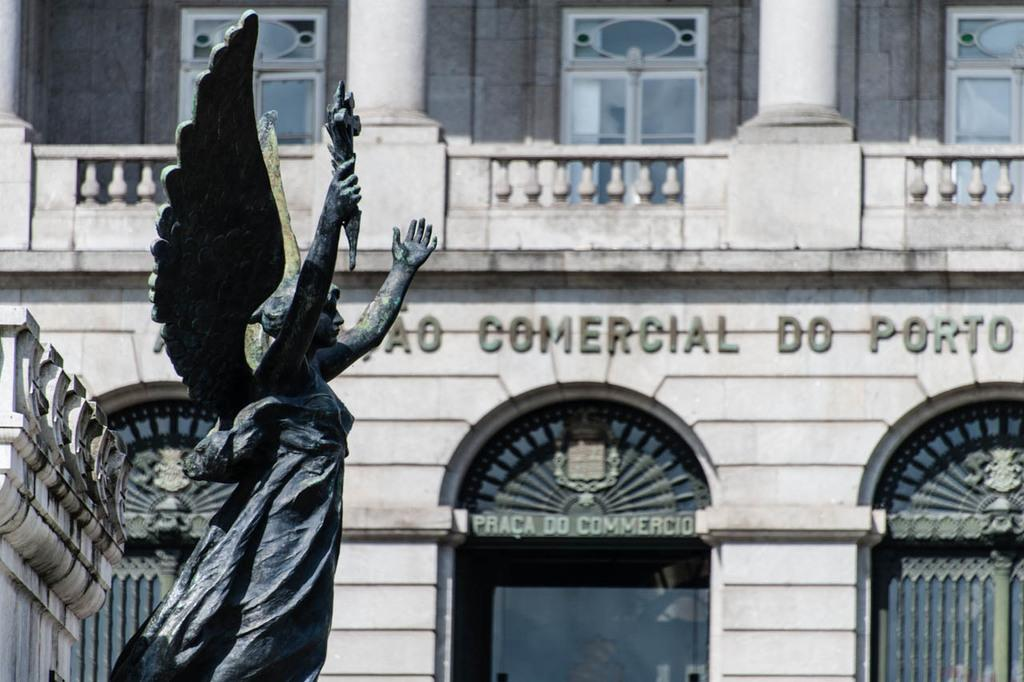What is the main subject in the foreground of the image? There is a statue in the foreground of the image. What can be seen in the background of the image? There is a building in the background of the image. What features can be observed on the building? The building has windows and poles. Is there any text visible on the building? Yes, there is some text on the building. How many bananas are hanging from the statue's neck in the image? There are no bananas or necks present in the image; it features a statue and a building. 